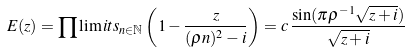Convert formula to latex. <formula><loc_0><loc_0><loc_500><loc_500>E ( z ) = \prod \lim i t s _ { n \in \mathbb { N } } \left ( 1 - \frac { z } { ( \rho n ) ^ { 2 } - i } \right ) = c \, \frac { \sin ( \pi \rho ^ { - 1 } \sqrt { z + i } ) } { \sqrt { z + i } }</formula> 